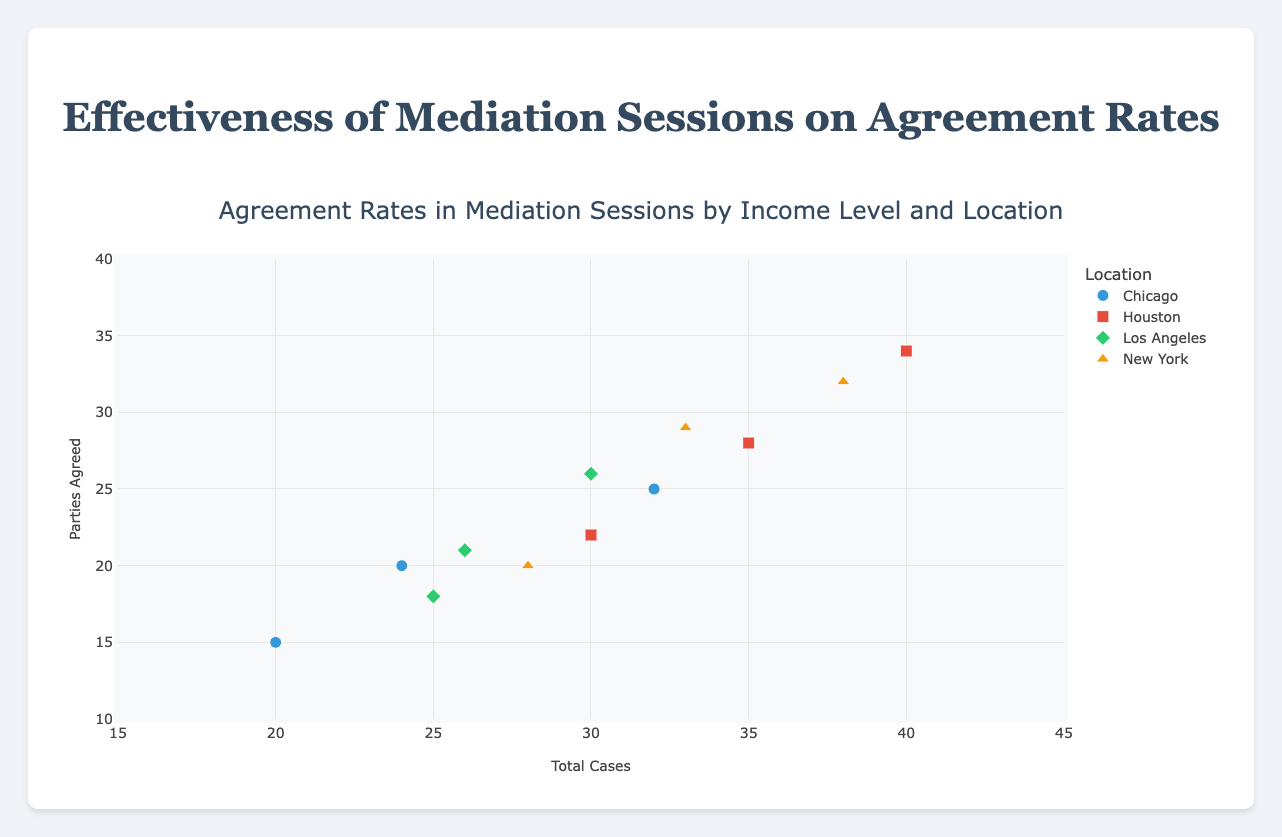What's the title of the plot? The title of the plot is clearly mentioned and can be found at the top of the figure.
Answer: Agreement Rates in Mediation Sessions by Income Level and Location What are the labels for the x-axis and y-axis? The labels for the axes are identified by looking at the titles assigned to each axis.
Answer: x-axis: Total Cases, y-axis: Parties Agreed How many locations are represented in the plot? The different locations are indicated by the distinct markers in the legend. Manually count the unique location names.
Answer: 4 Which location has the highest number of total cases? Look for the data point farthest to the right on the x-axis and check the legend to see which location it belongs to.
Answer: Houston Which income level shows the highest parties agreed in New York? Filter the New York data points and identify the highest y-value. Then, check the hover text for the corresponding income level.
Answer: High What is the total number of cases for Low-income levels in Chicago? Identify the data point for "Low" income level in Chicago and read the x-axis value.
Answer: 20 How many medium-income level cases are there in Los Angeles? Locate the "Medium" income level data point for Los Angeles and note the x-axis value.
Answer: 30 Which two cities have similar agreement rates for high-income levels? Compare the y-values (Parties Agreed) for the high income level data points across different cities.
Answer: New York and Los Angeles Which income level in Houston has the highest agreement rate? Evaluate the y-values for Houston's data points and find the one with the highest value. Check the income level from the hover text.
Answer: High In which location do low-income levels have the highest number of parties agreed? Compare the y-values for the low-income data points across all locations.
Answer: Houston 